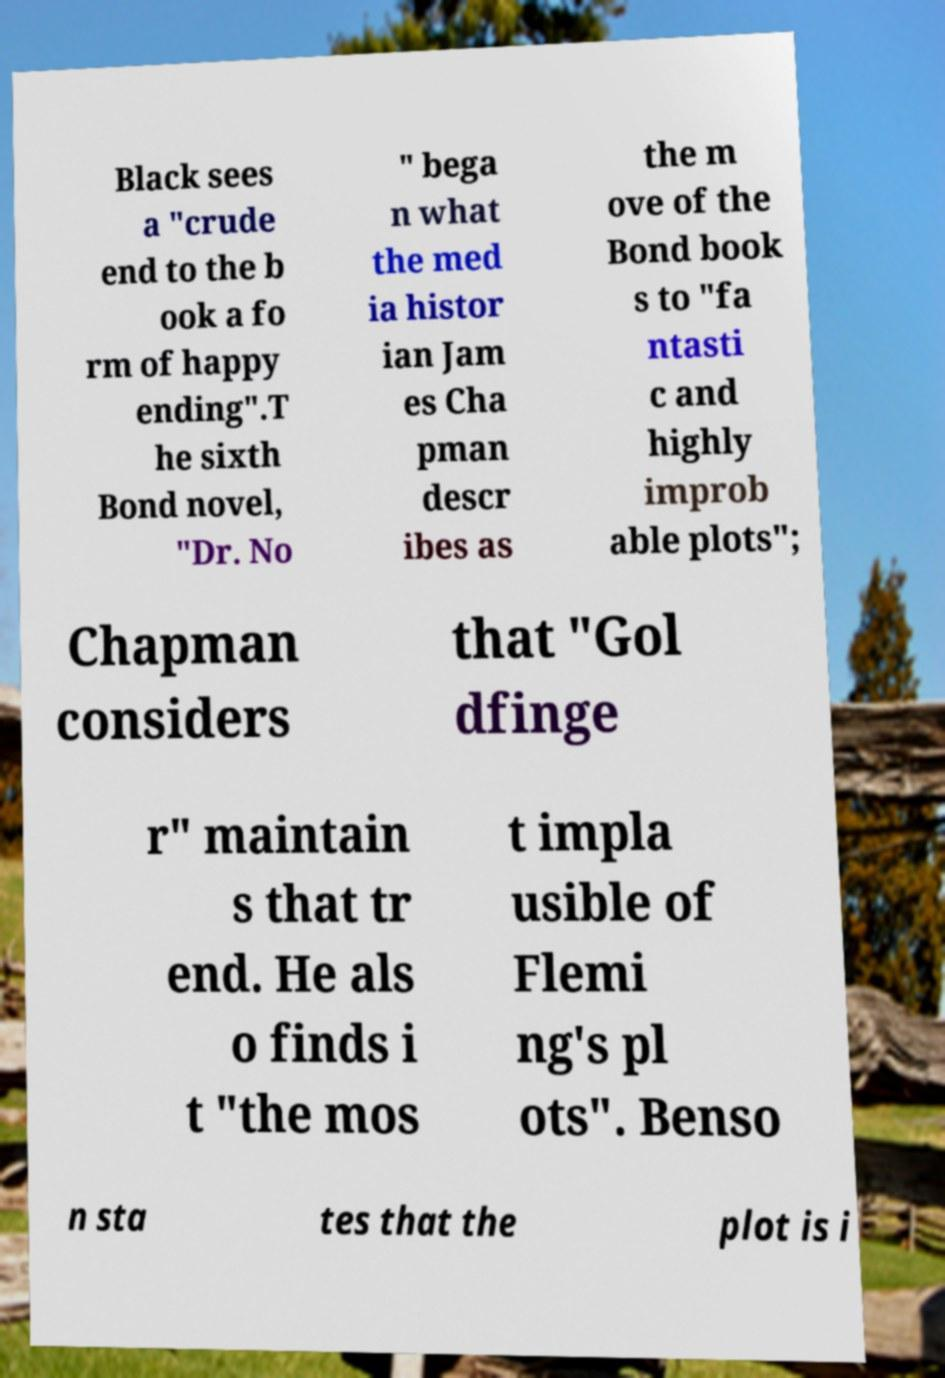For documentation purposes, I need the text within this image transcribed. Could you provide that? Black sees a "crude end to the b ook a fo rm of happy ending".T he sixth Bond novel, "Dr. No " bega n what the med ia histor ian Jam es Cha pman descr ibes as the m ove of the Bond book s to "fa ntasti c and highly improb able plots"; Chapman considers that "Gol dfinge r" maintain s that tr end. He als o finds i t "the mos t impla usible of Flemi ng's pl ots". Benso n sta tes that the plot is i 